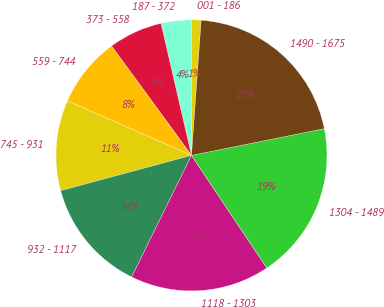Convert chart to OTSL. <chart><loc_0><loc_0><loc_500><loc_500><pie_chart><fcel>001 - 186<fcel>187 - 372<fcel>373 - 558<fcel>559 - 744<fcel>745 - 931<fcel>932 - 1117<fcel>1118 - 1303<fcel>1304 - 1489<fcel>1490 - 1675<nl><fcel>1.17%<fcel>3.58%<fcel>6.44%<fcel>8.36%<fcel>10.78%<fcel>13.53%<fcel>16.66%<fcel>18.78%<fcel>20.7%<nl></chart> 